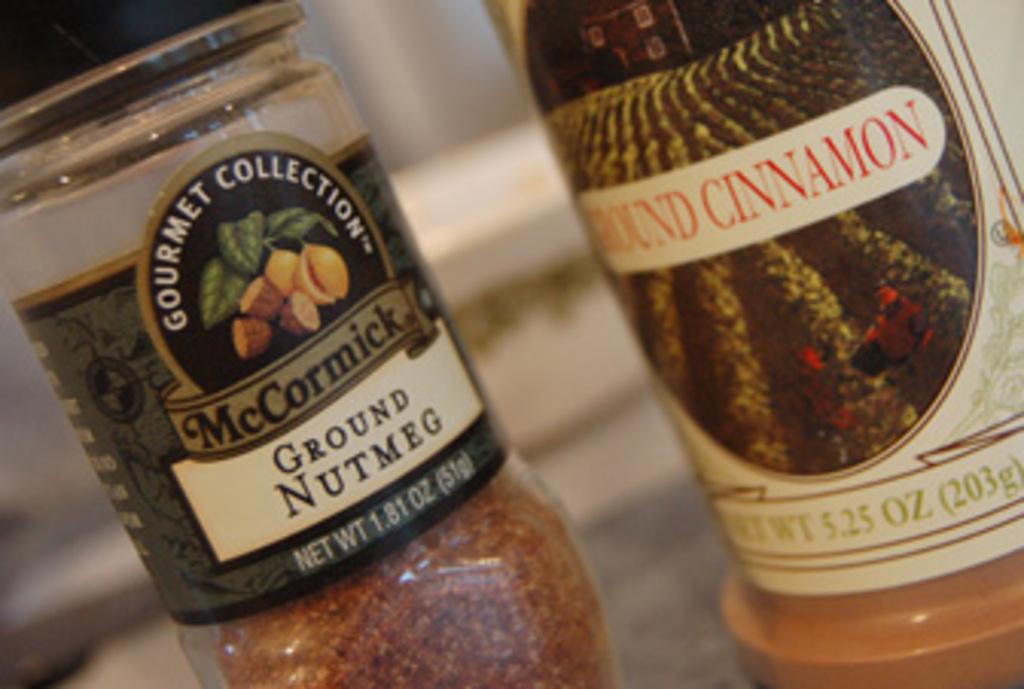Which is the nutmeg?
Offer a terse response. Mccormick. How many ounces does the bottle of cinnamon have?
Your answer should be very brief. 5.25. 